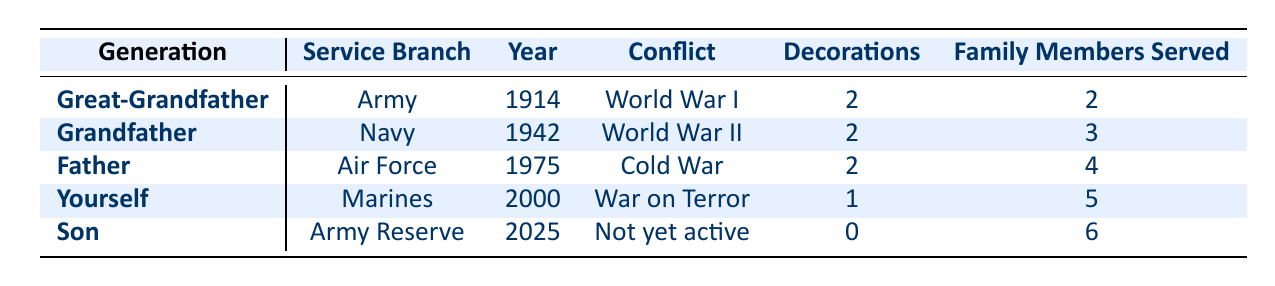What is the service branch of the Grandfather? The table lists the service branch for each family member. For the Grandfather, it states "Navy" in the Service Branch column.
Answer: Navy Which family member served in World War I? The table provides a list of conflicts served alongside the corresponding family members. The Great-Grandfather is the one who served in World War I as per the table.
Answer: Great-Grandfather How many family members served in total? To find the total number of family members served, we simply sum the "numberOfFamilyMembersServed" column: 2 + 3 + 4 + 5 + 6 = 20.
Answer: 20 Did the Father receive any decorations? The table specifies whether each family member received decorations. The Father has the "Air Medal" and "Meritorious Service Medal" listed in the Decorations column. Therefore, the answer is yes.
Answer: Yes Which generation had the most family members served? To determine which generation had the most family members served, we can compare the values in the "numberOfFamilyMembersServed" column: Great-Grandfather (2), Grandfather (3), Father (4), Yourself (5), Son (6). The Son has the highest number at 6.
Answer: Son What was the conflict that the Father served in? The conflict served by the Father is listed in the Conflicts Served column. According to the table, the Father served during the "Cold War."
Answer: Cold War Is it true that the Great-Grandfather received the Distinguished Service Cross? Checking the decorations of the Great-Grandfather in the Decorations column shows that he indeed received the Distinguished Service Cross. Thus, the answer is true.
Answer: True How many family members served in the Army branch? From the table, we see that the Great-Grandfather and the Son served in the Army (Great-Grandfather) and Army Reserve (Son). Adding these, we have a total of 2.
Answer: 2 What is the average number of family members that have served across the generations? To find the average, we total the family members served (2 + 3 + 4 + 5 + 6 = 20) and divide it by the number of generations (5). Thus, 20 / 5 = 4.
Answer: 4 Which generation has served the most recent? The table indicates that "Yourself" (David Thompson) served in the year 2000, which is the most recent entry.
Answer: Yourself 